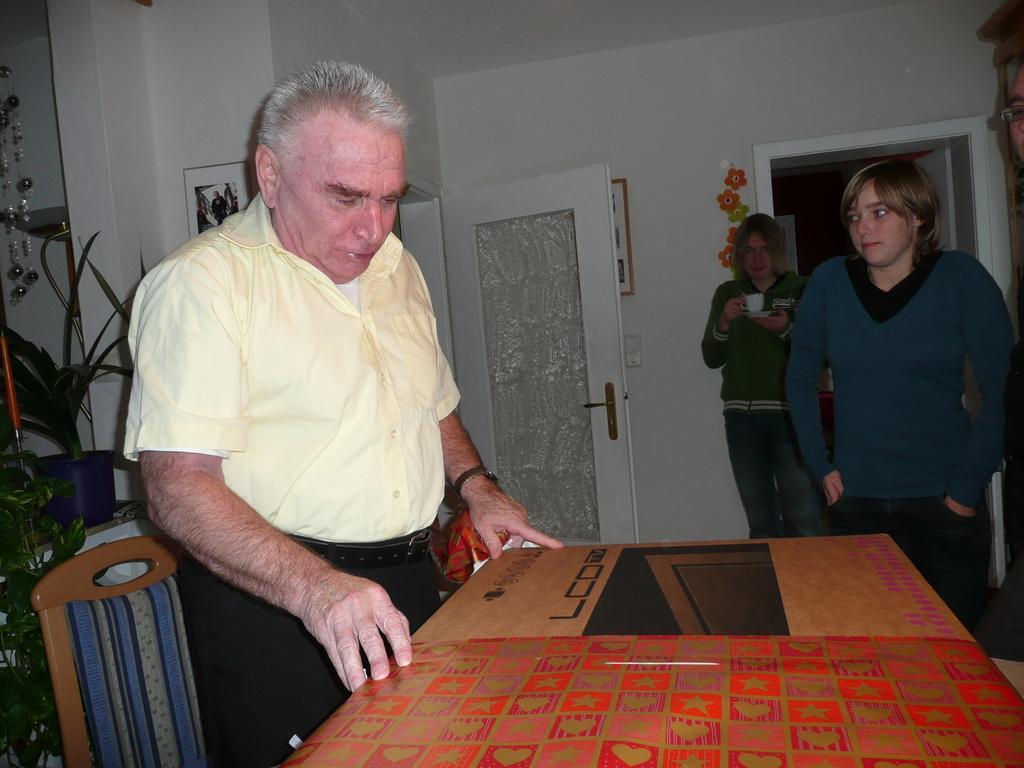Describe this image in one or two sentences. On the background we can see frames over a wall. These are doors. We can see persons standing near to the table here. This a chair. This is a houseplant. We can see one woman holding a cup with saucer in her hand. 